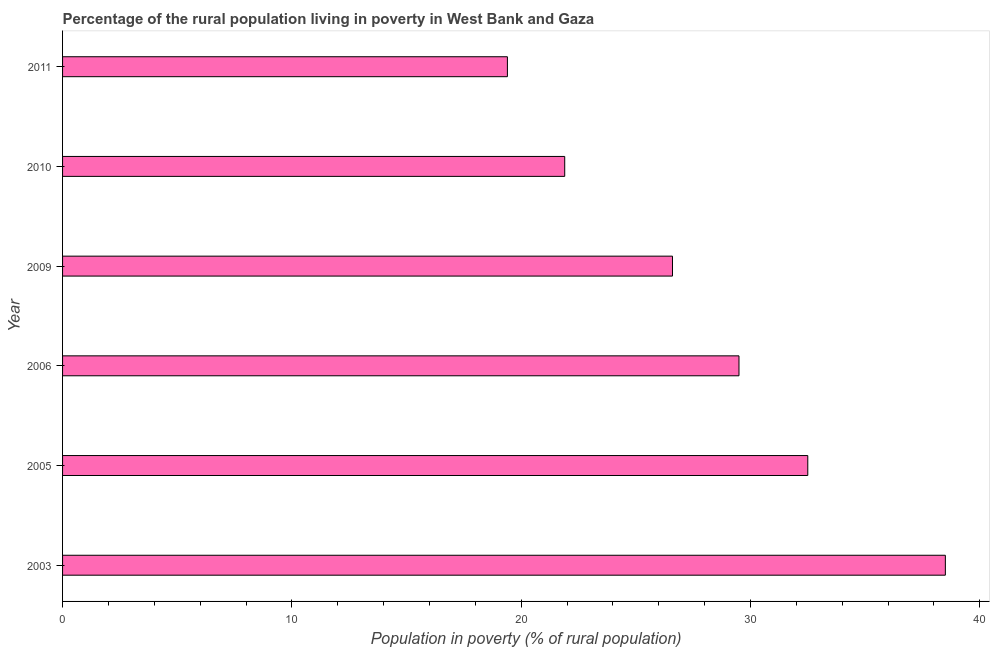Does the graph contain grids?
Ensure brevity in your answer.  No. What is the title of the graph?
Offer a very short reply. Percentage of the rural population living in poverty in West Bank and Gaza. What is the label or title of the X-axis?
Your answer should be compact. Population in poverty (% of rural population). What is the label or title of the Y-axis?
Make the answer very short. Year. What is the percentage of rural population living below poverty line in 2005?
Offer a very short reply. 32.5. Across all years, what is the maximum percentage of rural population living below poverty line?
Ensure brevity in your answer.  38.5. Across all years, what is the minimum percentage of rural population living below poverty line?
Ensure brevity in your answer.  19.4. In which year was the percentage of rural population living below poverty line maximum?
Ensure brevity in your answer.  2003. What is the sum of the percentage of rural population living below poverty line?
Ensure brevity in your answer.  168.4. What is the difference between the percentage of rural population living below poverty line in 2003 and 2005?
Your answer should be very brief. 6. What is the average percentage of rural population living below poverty line per year?
Give a very brief answer. 28.07. What is the median percentage of rural population living below poverty line?
Your answer should be compact. 28.05. Do a majority of the years between 2011 and 2010 (inclusive) have percentage of rural population living below poverty line greater than 4 %?
Give a very brief answer. No. What is the ratio of the percentage of rural population living below poverty line in 2003 to that in 2006?
Your answer should be compact. 1.3. Is the percentage of rural population living below poverty line in 2005 less than that in 2006?
Offer a very short reply. No. What is the difference between the highest and the second highest percentage of rural population living below poverty line?
Keep it short and to the point. 6. What is the difference between the highest and the lowest percentage of rural population living below poverty line?
Your answer should be compact. 19.1. In how many years, is the percentage of rural population living below poverty line greater than the average percentage of rural population living below poverty line taken over all years?
Provide a short and direct response. 3. How many bars are there?
Your answer should be very brief. 6. Are all the bars in the graph horizontal?
Offer a very short reply. Yes. How many years are there in the graph?
Keep it short and to the point. 6. What is the difference between two consecutive major ticks on the X-axis?
Keep it short and to the point. 10. What is the Population in poverty (% of rural population) in 2003?
Provide a succinct answer. 38.5. What is the Population in poverty (% of rural population) of 2005?
Provide a succinct answer. 32.5. What is the Population in poverty (% of rural population) of 2006?
Offer a very short reply. 29.5. What is the Population in poverty (% of rural population) in 2009?
Your response must be concise. 26.6. What is the Population in poverty (% of rural population) in 2010?
Make the answer very short. 21.9. What is the difference between the Population in poverty (% of rural population) in 2003 and 2006?
Offer a very short reply. 9. What is the difference between the Population in poverty (% of rural population) in 2003 and 2009?
Offer a very short reply. 11.9. What is the difference between the Population in poverty (% of rural population) in 2005 and 2009?
Provide a succinct answer. 5.9. What is the difference between the Population in poverty (% of rural population) in 2005 and 2010?
Your response must be concise. 10.6. What is the difference between the Population in poverty (% of rural population) in 2006 and 2009?
Give a very brief answer. 2.9. What is the difference between the Population in poverty (% of rural population) in 2006 and 2011?
Make the answer very short. 10.1. What is the difference between the Population in poverty (% of rural population) in 2009 and 2011?
Offer a very short reply. 7.2. What is the difference between the Population in poverty (% of rural population) in 2010 and 2011?
Give a very brief answer. 2.5. What is the ratio of the Population in poverty (% of rural population) in 2003 to that in 2005?
Ensure brevity in your answer.  1.19. What is the ratio of the Population in poverty (% of rural population) in 2003 to that in 2006?
Offer a very short reply. 1.3. What is the ratio of the Population in poverty (% of rural population) in 2003 to that in 2009?
Provide a short and direct response. 1.45. What is the ratio of the Population in poverty (% of rural population) in 2003 to that in 2010?
Offer a terse response. 1.76. What is the ratio of the Population in poverty (% of rural population) in 2003 to that in 2011?
Keep it short and to the point. 1.99. What is the ratio of the Population in poverty (% of rural population) in 2005 to that in 2006?
Your response must be concise. 1.1. What is the ratio of the Population in poverty (% of rural population) in 2005 to that in 2009?
Offer a very short reply. 1.22. What is the ratio of the Population in poverty (% of rural population) in 2005 to that in 2010?
Ensure brevity in your answer.  1.48. What is the ratio of the Population in poverty (% of rural population) in 2005 to that in 2011?
Ensure brevity in your answer.  1.68. What is the ratio of the Population in poverty (% of rural population) in 2006 to that in 2009?
Offer a very short reply. 1.11. What is the ratio of the Population in poverty (% of rural population) in 2006 to that in 2010?
Ensure brevity in your answer.  1.35. What is the ratio of the Population in poverty (% of rural population) in 2006 to that in 2011?
Provide a short and direct response. 1.52. What is the ratio of the Population in poverty (% of rural population) in 2009 to that in 2010?
Ensure brevity in your answer.  1.22. What is the ratio of the Population in poverty (% of rural population) in 2009 to that in 2011?
Make the answer very short. 1.37. What is the ratio of the Population in poverty (% of rural population) in 2010 to that in 2011?
Your answer should be very brief. 1.13. 